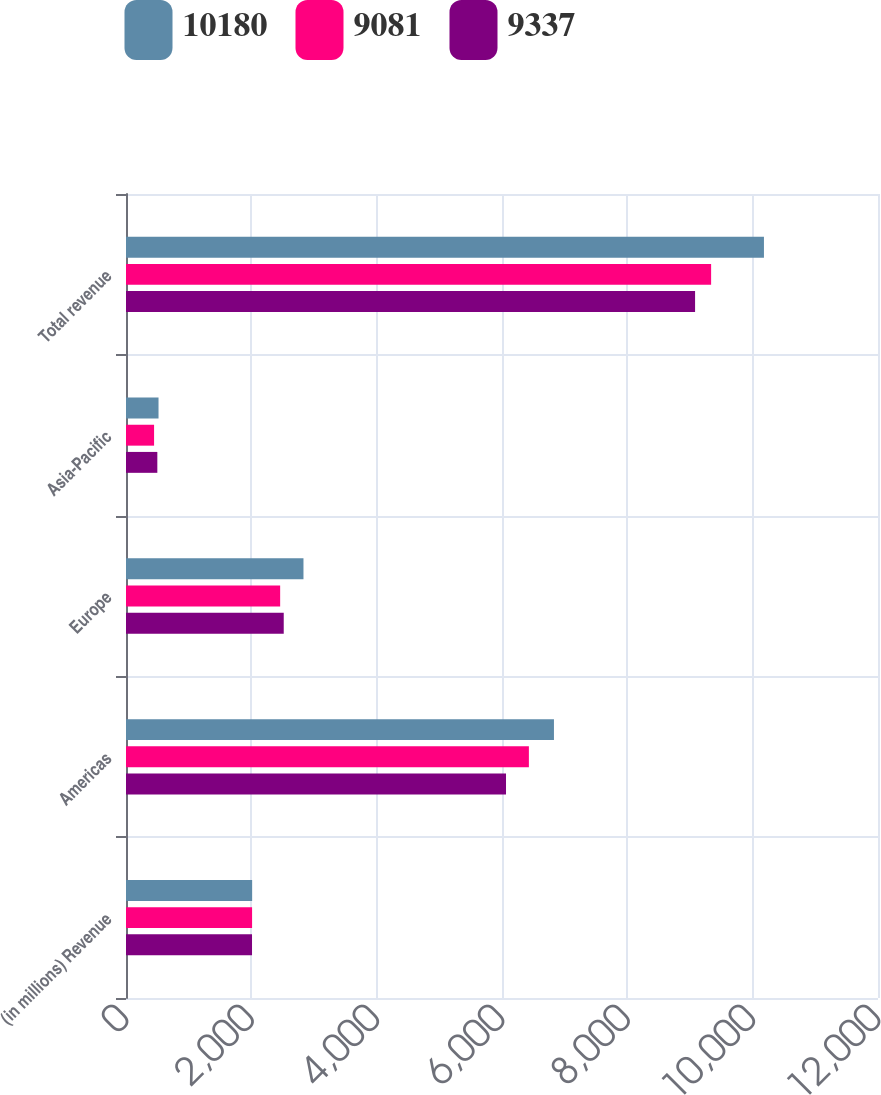Convert chart to OTSL. <chart><loc_0><loc_0><loc_500><loc_500><stacked_bar_chart><ecel><fcel>(in millions) Revenue<fcel>Americas<fcel>Europe<fcel>Asia-Pacific<fcel>Total revenue<nl><fcel>10180<fcel>2013<fcel>6829<fcel>2832<fcel>519<fcel>10180<nl><fcel>9081<fcel>2012<fcel>6429<fcel>2460<fcel>448<fcel>9337<nl><fcel>9337<fcel>2011<fcel>6064<fcel>2517<fcel>500<fcel>9081<nl></chart> 